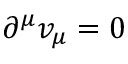<formula> <loc_0><loc_0><loc_500><loc_500>\partial ^ { \mu } v _ { \mu } = 0</formula> 